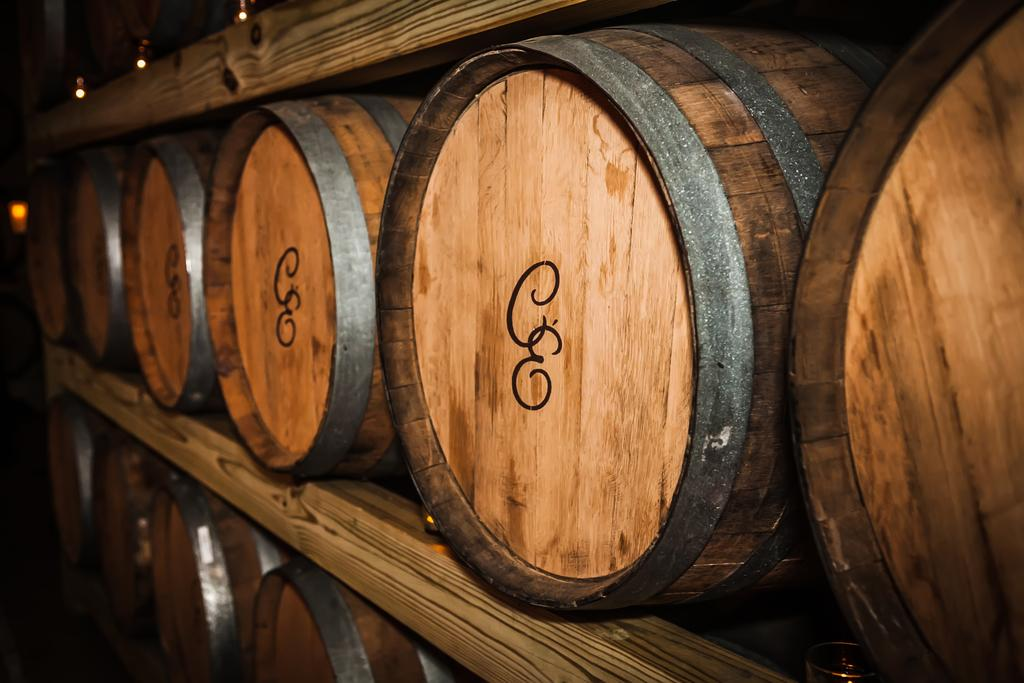What objects are stored on the shelf in the image? There are barrels on the shelf in the image. What can be seen in the image that provides illumination? There are lights in the image. Can you describe the possible location where the image was taken? The image may have been taken in a hall. What time of day might the image have been taken? The image may have been taken during nighttime. What type of cloth is draped over the coat in the image? There is no cloth or coat present in the image; it only features barrels on a shelf and lights. 